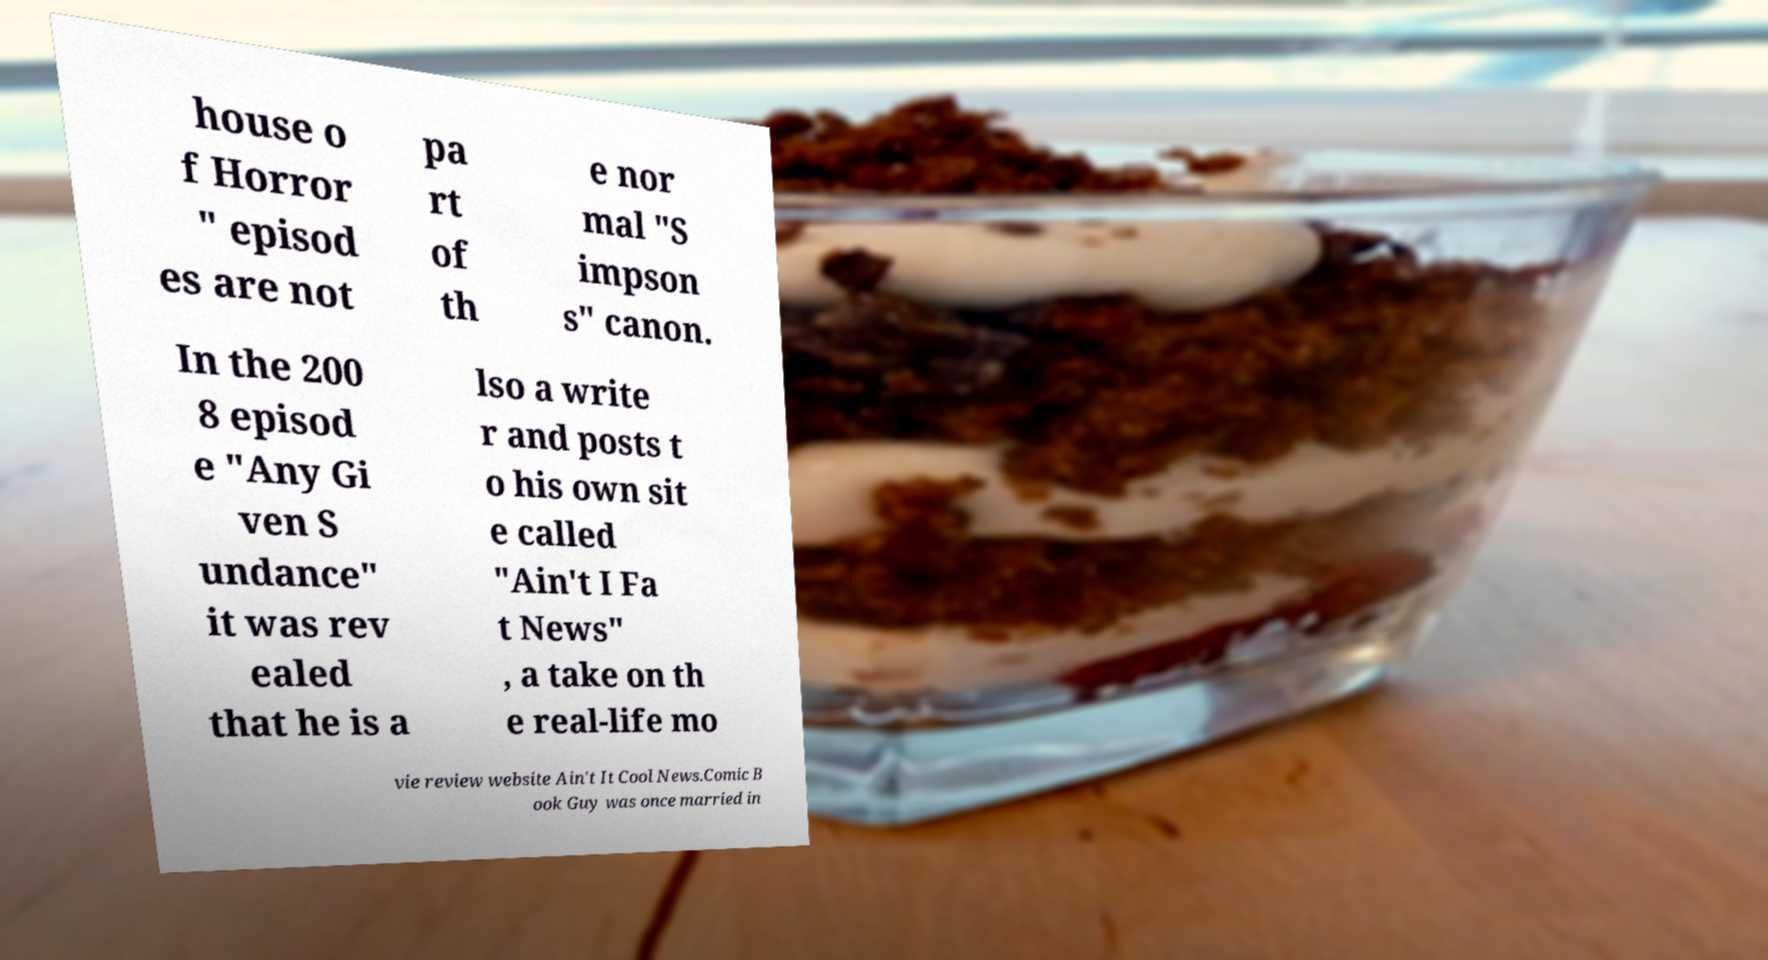What messages or text are displayed in this image? I need them in a readable, typed format. house o f Horror " episod es are not pa rt of th e nor mal "S impson s" canon. In the 200 8 episod e "Any Gi ven S undance" it was rev ealed that he is a lso a write r and posts t o his own sit e called "Ain't I Fa t News" , a take on th e real-life mo vie review website Ain't It Cool News.Comic B ook Guy was once married in 